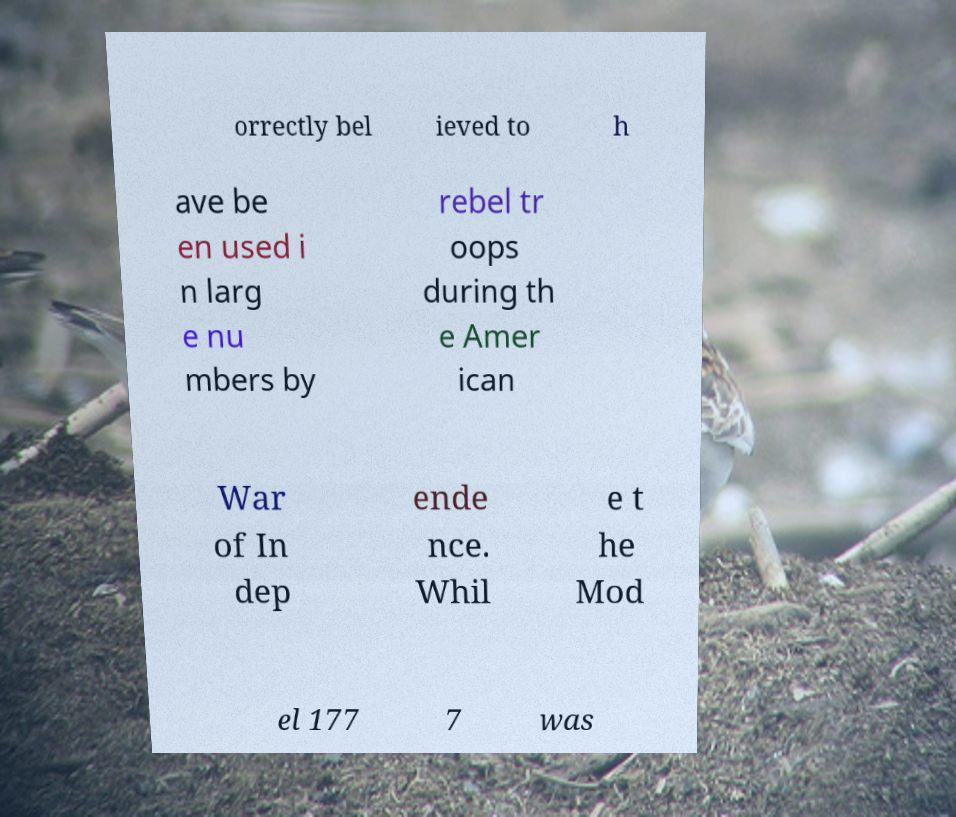What messages or text are displayed in this image? I need them in a readable, typed format. orrectly bel ieved to h ave be en used i n larg e nu mbers by rebel tr oops during th e Amer ican War of In dep ende nce. Whil e t he Mod el 177 7 was 